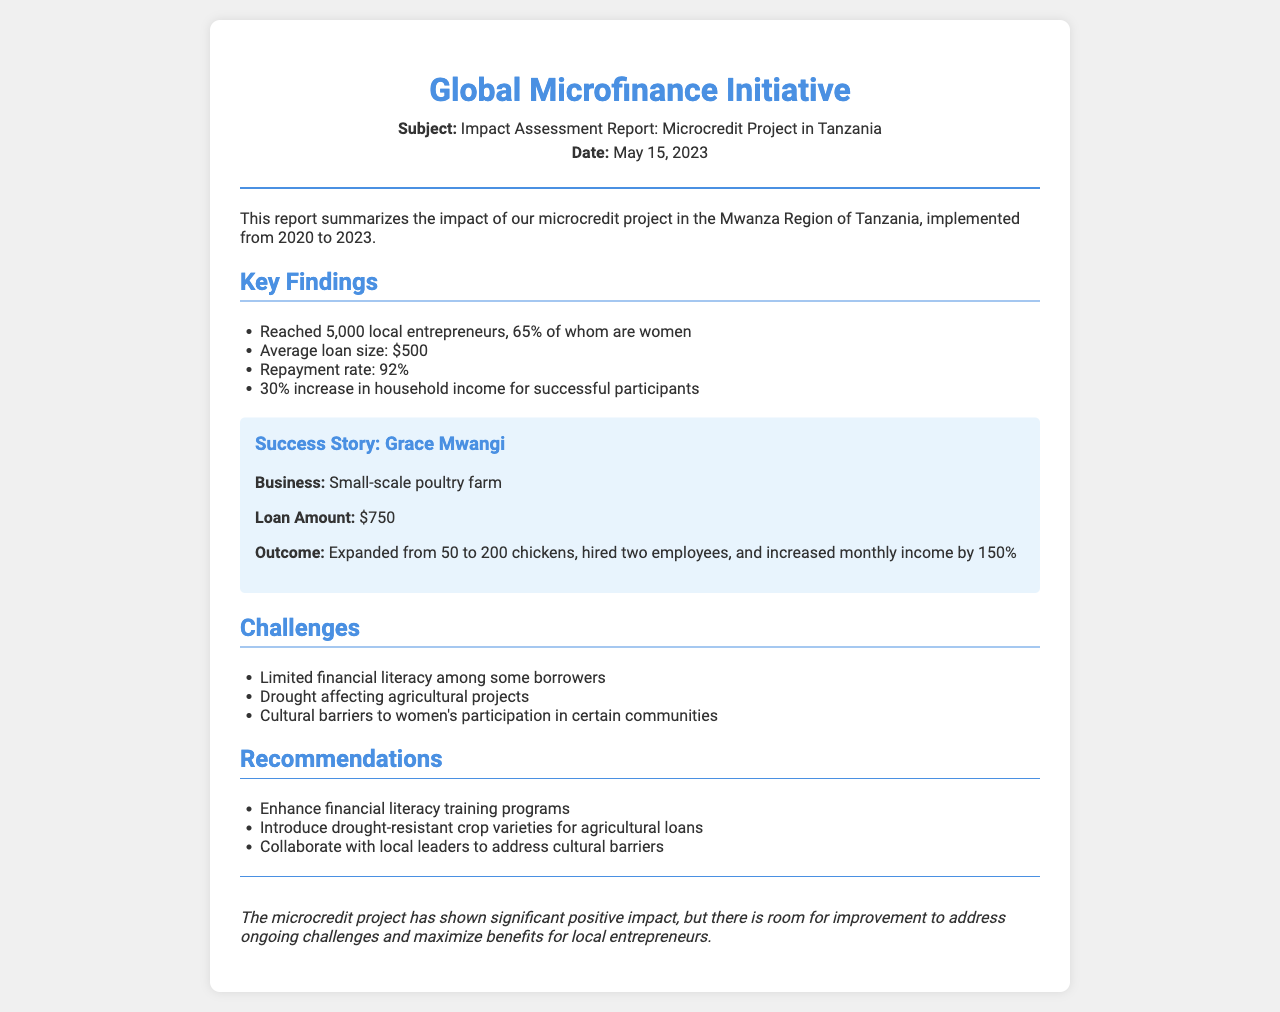What is the subject of the fax? The subject of the fax is stated in the header section as the impact assessment report.
Answer: Impact Assessment Report: Microcredit Project in Tanzania How many local entrepreneurs were reached? The number of local entrepreneurs is mentioned under key findings.
Answer: 5,000 What is the average loan size? The average loan size is indicated in the key findings section.
Answer: $500 What percentage of participants experienced an increase in household income? The percentage of participants who saw an increase in household income is listed in the key findings.
Answer: 30% What was one significant outcome of Grace Mwangi's business? The outcome of her business is highlighted in her success story.
Answer: Increased monthly income by 150% What is one of the challenges mentioned in the document? The challenges are listed in a dedicated section.
Answer: Limited financial literacy among some borrowers What is a recommendation made in the report? Recommendations are provided in their own section in the document.
Answer: Enhance financial literacy training programs What is the repayment rate? The repayment rate is included within the key findings.
Answer: 92% What was the date of the report? The report date is mentioned in the header.
Answer: May 15, 2023 